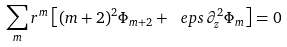Convert formula to latex. <formula><loc_0><loc_0><loc_500><loc_500>\sum _ { m } r ^ { m } \left [ ( m + 2 ) ^ { 2 } \Phi _ { m + 2 } + \ e p s \, \partial ^ { 2 } _ { z } \Phi _ { m } \right ] = 0</formula> 